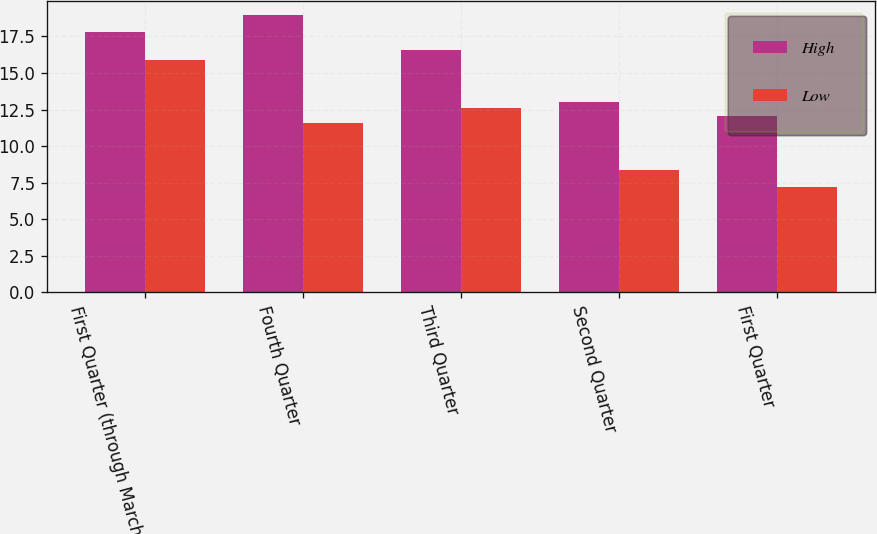Convert chart to OTSL. <chart><loc_0><loc_0><loc_500><loc_500><stacked_bar_chart><ecel><fcel>First Quarter (through March<fcel>Fourth Quarter<fcel>Third Quarter<fcel>Second Quarter<fcel>First Quarter<nl><fcel>High<fcel>17.84<fcel>18.96<fcel>16.58<fcel>13.04<fcel>12.08<nl><fcel>Low<fcel>15.9<fcel>11.56<fcel>12.58<fcel>8.33<fcel>7.21<nl></chart> 